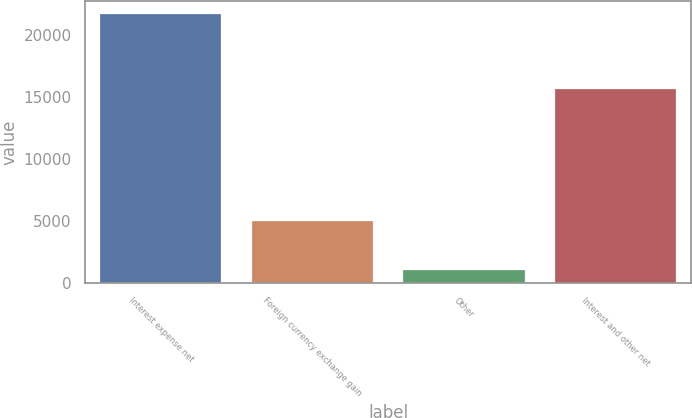Convert chart to OTSL. <chart><loc_0><loc_0><loc_500><loc_500><bar_chart><fcel>Interest expense net<fcel>Foreign currency exchange gain<fcel>Other<fcel>Interest and other net<nl><fcel>21700<fcel>4990<fcel>1020<fcel>15690<nl></chart> 